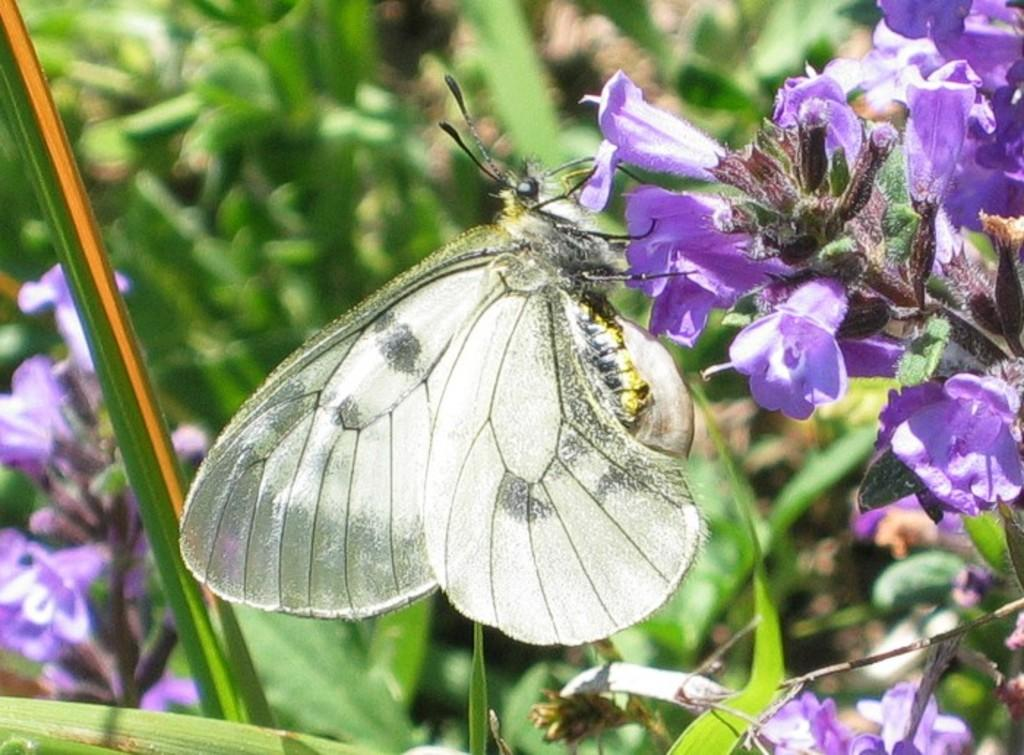What types of living organisms can be seen in the image? Plants and flowers are visible in the image. Are there any insects present in the image? Yes, there is a butterfly in the image. What type of fruit can be seen hanging from the plants in the image? There is no fruit visible in the image; only plants, flowers, and a butterfly are present. 